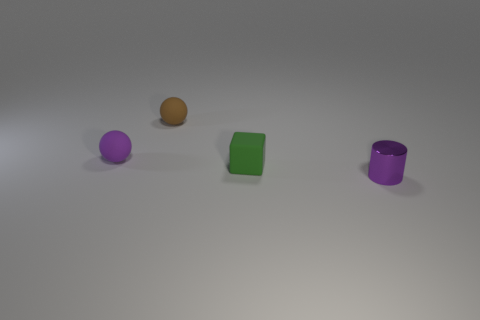Add 1 purple matte balls. How many objects exist? 5 Subtract all purple spheres. How many spheres are left? 1 Subtract 0 red spheres. How many objects are left? 4 Subtract all blocks. How many objects are left? 3 Subtract 2 balls. How many balls are left? 0 Subtract all purple balls. Subtract all yellow blocks. How many balls are left? 1 Subtract all purple cylinders. How many purple balls are left? 1 Subtract all red matte blocks. Subtract all tiny purple shiny cylinders. How many objects are left? 3 Add 1 blocks. How many blocks are left? 2 Add 2 green rubber blocks. How many green rubber blocks exist? 3 